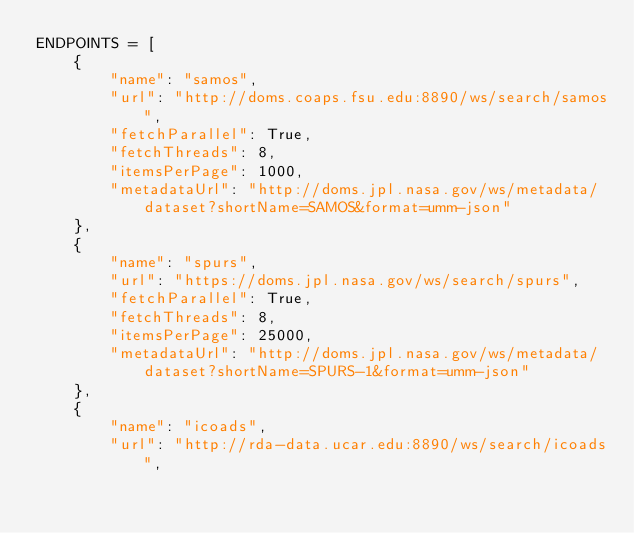<code> <loc_0><loc_0><loc_500><loc_500><_Python_>ENDPOINTS = [
    {
        "name": "samos",
        "url": "http://doms.coaps.fsu.edu:8890/ws/search/samos",
        "fetchParallel": True,
        "fetchThreads": 8,
        "itemsPerPage": 1000,
        "metadataUrl": "http://doms.jpl.nasa.gov/ws/metadata/dataset?shortName=SAMOS&format=umm-json"
    },
    {
        "name": "spurs",
        "url": "https://doms.jpl.nasa.gov/ws/search/spurs",
        "fetchParallel": True,
        "fetchThreads": 8,
        "itemsPerPage": 25000,
        "metadataUrl": "http://doms.jpl.nasa.gov/ws/metadata/dataset?shortName=SPURS-1&format=umm-json"
    },
    {
        "name": "icoads",
        "url": "http://rda-data.ucar.edu:8890/ws/search/icoads",</code> 